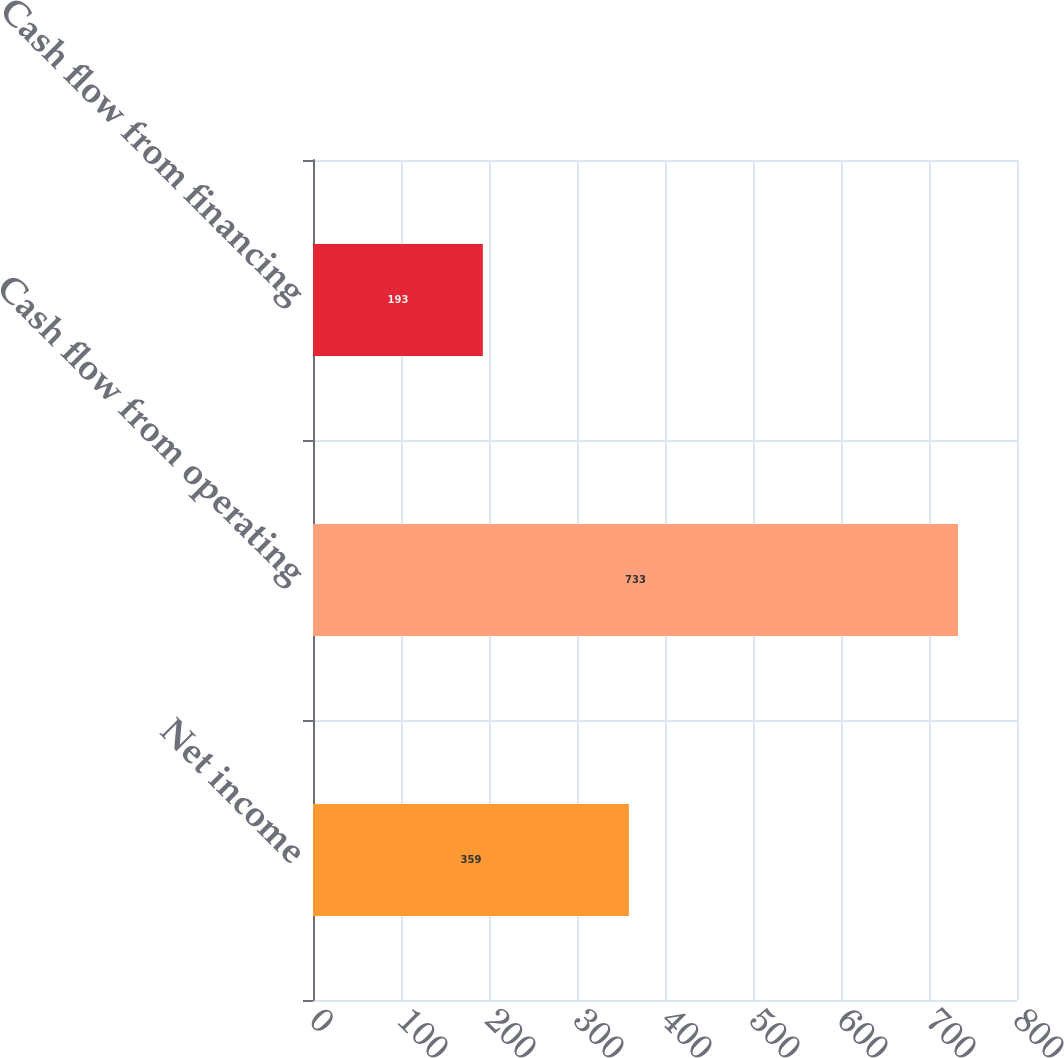Convert chart. <chart><loc_0><loc_0><loc_500><loc_500><bar_chart><fcel>Net income<fcel>Cash flow from operating<fcel>Cash flow from financing<nl><fcel>359<fcel>733<fcel>193<nl></chart> 